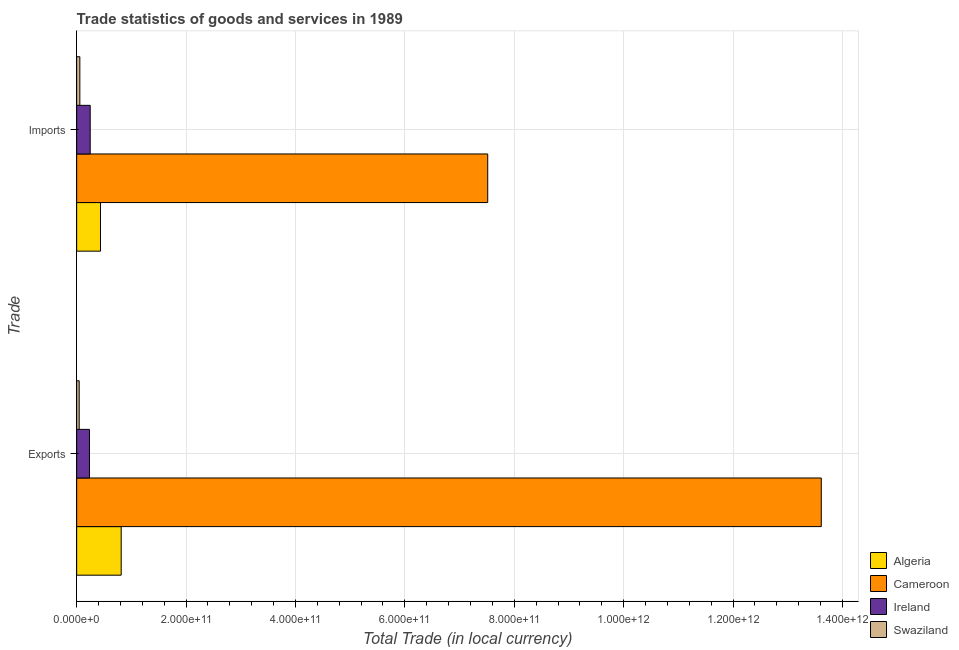How many different coloured bars are there?
Your answer should be compact. 4. Are the number of bars on each tick of the Y-axis equal?
Offer a terse response. Yes. What is the label of the 2nd group of bars from the top?
Make the answer very short. Exports. What is the imports of goods and services in Swaziland?
Make the answer very short. 5.83e+09. Across all countries, what is the maximum export of goods and services?
Offer a terse response. 1.36e+12. Across all countries, what is the minimum imports of goods and services?
Offer a terse response. 5.83e+09. In which country was the imports of goods and services maximum?
Your answer should be very brief. Cameroon. In which country was the export of goods and services minimum?
Make the answer very short. Swaziland. What is the total export of goods and services in the graph?
Offer a very short reply. 1.47e+12. What is the difference between the export of goods and services in Cameroon and that in Ireland?
Give a very brief answer. 1.34e+12. What is the difference between the export of goods and services in Ireland and the imports of goods and services in Cameroon?
Provide a succinct answer. -7.28e+11. What is the average imports of goods and services per country?
Provide a succinct answer. 2.06e+11. What is the difference between the export of goods and services and imports of goods and services in Cameroon?
Provide a short and direct response. 6.10e+11. What is the ratio of the imports of goods and services in Cameroon to that in Ireland?
Offer a very short reply. 30.36. What does the 3rd bar from the top in Imports represents?
Your answer should be very brief. Cameroon. What does the 3rd bar from the bottom in Imports represents?
Ensure brevity in your answer.  Ireland. How many bars are there?
Your answer should be very brief. 8. Are all the bars in the graph horizontal?
Ensure brevity in your answer.  Yes. How many countries are there in the graph?
Your response must be concise. 4. What is the difference between two consecutive major ticks on the X-axis?
Provide a succinct answer. 2.00e+11. Are the values on the major ticks of X-axis written in scientific E-notation?
Keep it short and to the point. Yes. Does the graph contain grids?
Offer a very short reply. Yes. How many legend labels are there?
Provide a succinct answer. 4. How are the legend labels stacked?
Make the answer very short. Vertical. What is the title of the graph?
Your response must be concise. Trade statistics of goods and services in 1989. Does "Northern Mariana Islands" appear as one of the legend labels in the graph?
Your answer should be very brief. No. What is the label or title of the X-axis?
Your answer should be very brief. Total Trade (in local currency). What is the label or title of the Y-axis?
Give a very brief answer. Trade. What is the Total Trade (in local currency) of Algeria in Exports?
Provide a succinct answer. 8.14e+1. What is the Total Trade (in local currency) of Cameroon in Exports?
Your answer should be very brief. 1.36e+12. What is the Total Trade (in local currency) in Ireland in Exports?
Ensure brevity in your answer.  2.34e+1. What is the Total Trade (in local currency) of Swaziland in Exports?
Your response must be concise. 4.61e+09. What is the Total Trade (in local currency) in Algeria in Imports?
Provide a short and direct response. 4.36e+1. What is the Total Trade (in local currency) in Cameroon in Imports?
Give a very brief answer. 7.52e+11. What is the Total Trade (in local currency) of Ireland in Imports?
Provide a short and direct response. 2.48e+1. What is the Total Trade (in local currency) of Swaziland in Imports?
Your answer should be compact. 5.83e+09. Across all Trade, what is the maximum Total Trade (in local currency) of Algeria?
Your response must be concise. 8.14e+1. Across all Trade, what is the maximum Total Trade (in local currency) in Cameroon?
Ensure brevity in your answer.  1.36e+12. Across all Trade, what is the maximum Total Trade (in local currency) in Ireland?
Offer a very short reply. 2.48e+1. Across all Trade, what is the maximum Total Trade (in local currency) of Swaziland?
Your response must be concise. 5.83e+09. Across all Trade, what is the minimum Total Trade (in local currency) of Algeria?
Your answer should be very brief. 4.36e+1. Across all Trade, what is the minimum Total Trade (in local currency) of Cameroon?
Give a very brief answer. 7.52e+11. Across all Trade, what is the minimum Total Trade (in local currency) of Ireland?
Your answer should be compact. 2.34e+1. Across all Trade, what is the minimum Total Trade (in local currency) in Swaziland?
Keep it short and to the point. 4.61e+09. What is the total Total Trade (in local currency) of Algeria in the graph?
Offer a terse response. 1.25e+11. What is the total Total Trade (in local currency) in Cameroon in the graph?
Provide a short and direct response. 2.11e+12. What is the total Total Trade (in local currency) of Ireland in the graph?
Give a very brief answer. 4.81e+1. What is the total Total Trade (in local currency) in Swaziland in the graph?
Your answer should be compact. 1.04e+1. What is the difference between the Total Trade (in local currency) in Algeria in Exports and that in Imports?
Keep it short and to the point. 3.78e+1. What is the difference between the Total Trade (in local currency) in Cameroon in Exports and that in Imports?
Offer a very short reply. 6.10e+11. What is the difference between the Total Trade (in local currency) of Ireland in Exports and that in Imports?
Provide a succinct answer. -1.36e+09. What is the difference between the Total Trade (in local currency) in Swaziland in Exports and that in Imports?
Offer a terse response. -1.22e+09. What is the difference between the Total Trade (in local currency) in Algeria in Exports and the Total Trade (in local currency) in Cameroon in Imports?
Make the answer very short. -6.70e+11. What is the difference between the Total Trade (in local currency) in Algeria in Exports and the Total Trade (in local currency) in Ireland in Imports?
Provide a succinct answer. 5.66e+1. What is the difference between the Total Trade (in local currency) in Algeria in Exports and the Total Trade (in local currency) in Swaziland in Imports?
Offer a very short reply. 7.56e+1. What is the difference between the Total Trade (in local currency) in Cameroon in Exports and the Total Trade (in local currency) in Ireland in Imports?
Ensure brevity in your answer.  1.34e+12. What is the difference between the Total Trade (in local currency) in Cameroon in Exports and the Total Trade (in local currency) in Swaziland in Imports?
Give a very brief answer. 1.36e+12. What is the difference between the Total Trade (in local currency) of Ireland in Exports and the Total Trade (in local currency) of Swaziland in Imports?
Keep it short and to the point. 1.76e+1. What is the average Total Trade (in local currency) of Algeria per Trade?
Offer a very short reply. 6.25e+1. What is the average Total Trade (in local currency) of Cameroon per Trade?
Ensure brevity in your answer.  1.06e+12. What is the average Total Trade (in local currency) in Ireland per Trade?
Give a very brief answer. 2.41e+1. What is the average Total Trade (in local currency) in Swaziland per Trade?
Offer a very short reply. 5.22e+09. What is the difference between the Total Trade (in local currency) of Algeria and Total Trade (in local currency) of Cameroon in Exports?
Ensure brevity in your answer.  -1.28e+12. What is the difference between the Total Trade (in local currency) of Algeria and Total Trade (in local currency) of Ireland in Exports?
Ensure brevity in your answer.  5.80e+1. What is the difference between the Total Trade (in local currency) in Algeria and Total Trade (in local currency) in Swaziland in Exports?
Your answer should be very brief. 7.68e+1. What is the difference between the Total Trade (in local currency) of Cameroon and Total Trade (in local currency) of Ireland in Exports?
Ensure brevity in your answer.  1.34e+12. What is the difference between the Total Trade (in local currency) in Cameroon and Total Trade (in local currency) in Swaziland in Exports?
Keep it short and to the point. 1.36e+12. What is the difference between the Total Trade (in local currency) in Ireland and Total Trade (in local currency) in Swaziland in Exports?
Ensure brevity in your answer.  1.88e+1. What is the difference between the Total Trade (in local currency) of Algeria and Total Trade (in local currency) of Cameroon in Imports?
Provide a succinct answer. -7.08e+11. What is the difference between the Total Trade (in local currency) of Algeria and Total Trade (in local currency) of Ireland in Imports?
Make the answer very short. 1.88e+1. What is the difference between the Total Trade (in local currency) in Algeria and Total Trade (in local currency) in Swaziland in Imports?
Give a very brief answer. 3.77e+1. What is the difference between the Total Trade (in local currency) of Cameroon and Total Trade (in local currency) of Ireland in Imports?
Your answer should be compact. 7.27e+11. What is the difference between the Total Trade (in local currency) in Cameroon and Total Trade (in local currency) in Swaziland in Imports?
Your answer should be compact. 7.46e+11. What is the difference between the Total Trade (in local currency) in Ireland and Total Trade (in local currency) in Swaziland in Imports?
Offer a terse response. 1.89e+1. What is the ratio of the Total Trade (in local currency) of Algeria in Exports to that in Imports?
Ensure brevity in your answer.  1.87. What is the ratio of the Total Trade (in local currency) of Cameroon in Exports to that in Imports?
Your response must be concise. 1.81. What is the ratio of the Total Trade (in local currency) in Ireland in Exports to that in Imports?
Your answer should be compact. 0.95. What is the ratio of the Total Trade (in local currency) in Swaziland in Exports to that in Imports?
Make the answer very short. 0.79. What is the difference between the highest and the second highest Total Trade (in local currency) of Algeria?
Offer a very short reply. 3.78e+1. What is the difference between the highest and the second highest Total Trade (in local currency) of Cameroon?
Make the answer very short. 6.10e+11. What is the difference between the highest and the second highest Total Trade (in local currency) of Ireland?
Give a very brief answer. 1.36e+09. What is the difference between the highest and the second highest Total Trade (in local currency) of Swaziland?
Provide a short and direct response. 1.22e+09. What is the difference between the highest and the lowest Total Trade (in local currency) of Algeria?
Your answer should be very brief. 3.78e+1. What is the difference between the highest and the lowest Total Trade (in local currency) of Cameroon?
Keep it short and to the point. 6.10e+11. What is the difference between the highest and the lowest Total Trade (in local currency) of Ireland?
Provide a short and direct response. 1.36e+09. What is the difference between the highest and the lowest Total Trade (in local currency) in Swaziland?
Make the answer very short. 1.22e+09. 